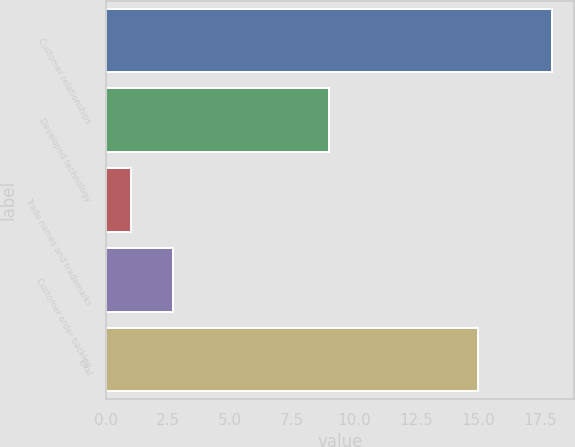Convert chart. <chart><loc_0><loc_0><loc_500><loc_500><bar_chart><fcel>Customer relationships<fcel>Developed technology<fcel>Trade names and trademarks<fcel>Customer order backlog<fcel>Total<nl><fcel>18<fcel>9<fcel>1<fcel>2.7<fcel>15<nl></chart> 